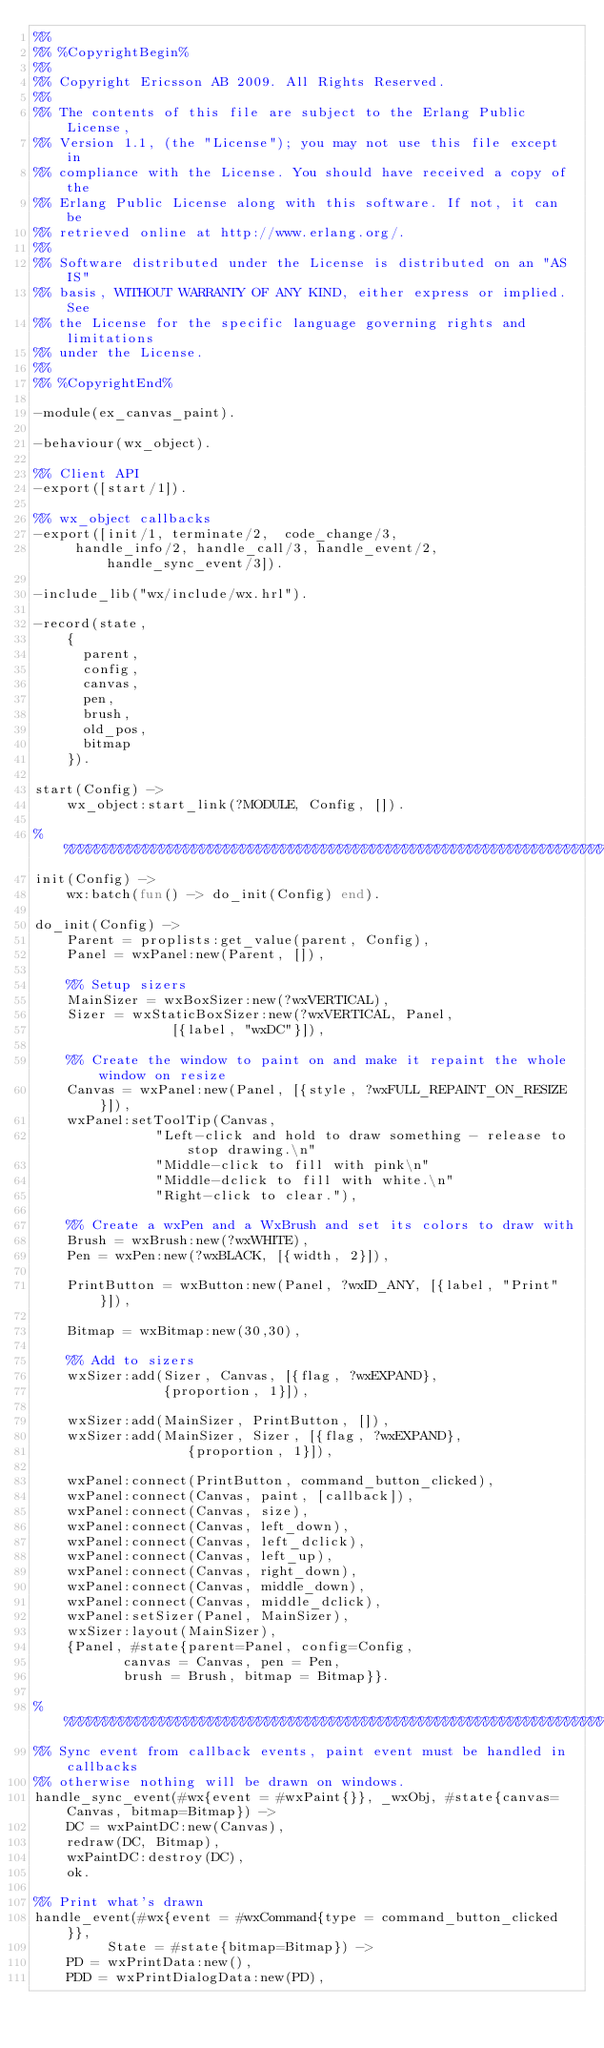Convert code to text. <code><loc_0><loc_0><loc_500><loc_500><_Erlang_>%%
%% %CopyrightBegin%
%% 
%% Copyright Ericsson AB 2009. All Rights Reserved.
%% 
%% The contents of this file are subject to the Erlang Public License,
%% Version 1.1, (the "License"); you may not use this file except in
%% compliance with the License. You should have received a copy of the
%% Erlang Public License along with this software. If not, it can be
%% retrieved online at http://www.erlang.org/.
%% 
%% Software distributed under the License is distributed on an "AS IS"
%% basis, WITHOUT WARRANTY OF ANY KIND, either express or implied. See
%% the License for the specific language governing rights and limitations
%% under the License.
%% 
%% %CopyrightEnd%

-module(ex_canvas_paint).

-behaviour(wx_object).

%% Client API
-export([start/1]).

%% wx_object callbacks
-export([init/1, terminate/2,  code_change/3,
	 handle_info/2, handle_call/3, handle_event/2, handle_sync_event/3]).

-include_lib("wx/include/wx.hrl").

-record(state, 
	{
	  parent,
	  config,
	  canvas,
	  pen,
	  brush,
	  old_pos,
	  bitmap
	}).

start(Config) ->
    wx_object:start_link(?MODULE, Config, []).

%%%%%%%%%%%%%%%%%%%%%%%%%%%%%%%%%%%%%%%%%%%%%%%%%%%%%%%%%%%%%%%%%%%%%%%%%%%%%%%
init(Config) ->
    wx:batch(fun() -> do_init(Config) end).

do_init(Config) ->
    Parent = proplists:get_value(parent, Config),  
    Panel = wxPanel:new(Parent, []),

    %% Setup sizers
    MainSizer = wxBoxSizer:new(?wxVERTICAL),
    Sizer = wxStaticBoxSizer:new(?wxVERTICAL, Panel, 
				 [{label, "wxDC"}]),
    
    %% Create the window to paint on and make it repaint the whole window on resize
    Canvas = wxPanel:new(Panel, [{style, ?wxFULL_REPAINT_ON_RESIZE}]),
    wxPanel:setToolTip(Canvas,
		       "Left-click and hold to draw something - release to stop drawing.\n"
		       "Middle-click to fill with pink\n"
		       "Middle-dclick to fill with white.\n"
		       "Right-click to clear."),

    %% Create a wxPen and a WxBrush and set its colors to draw with
    Brush = wxBrush:new(?wxWHITE),
    Pen = wxPen:new(?wxBLACK, [{width, 2}]),
    
    PrintButton = wxButton:new(Panel, ?wxID_ANY, [{label, "Print"}]),

    Bitmap = wxBitmap:new(30,30),

    %% Add to sizers
    wxSizer:add(Sizer, Canvas, [{flag, ?wxEXPAND},
				{proportion, 1}]),

    wxSizer:add(MainSizer, PrintButton, []),
    wxSizer:add(MainSizer, Sizer, [{flag, ?wxEXPAND},
				   {proportion, 1}]),
    
    wxPanel:connect(PrintButton, command_button_clicked),
    wxPanel:connect(Canvas, paint, [callback]),
    wxPanel:connect(Canvas, size),
    wxPanel:connect(Canvas, left_down),
    wxPanel:connect(Canvas, left_dclick),
    wxPanel:connect(Canvas, left_up),
    wxPanel:connect(Canvas, right_down),
    wxPanel:connect(Canvas, middle_down),
    wxPanel:connect(Canvas, middle_dclick),
    wxPanel:setSizer(Panel, MainSizer),
    wxSizer:layout(MainSizer),
    {Panel, #state{parent=Panel, config=Config,
		   canvas = Canvas, pen = Pen,
		   brush = Brush, bitmap = Bitmap}}.

%%%%%%%%%%%%%%%%%%%%%%%%%%%%%%%%%%%%%%%%%%%%%%%%%%%%%%%%%%%%%%%%%%%%%%%%%%%%%%%
%% Sync event from callback events, paint event must be handled in callbacks
%% otherwise nothing will be drawn on windows.
handle_sync_event(#wx{event = #wxPaint{}}, _wxObj, #state{canvas=Canvas, bitmap=Bitmap}) ->
    DC = wxPaintDC:new(Canvas),
    redraw(DC, Bitmap),
    wxPaintDC:destroy(DC),
    ok.

%% Print what's drawn
handle_event(#wx{event = #wxCommand{type = command_button_clicked}},
	     State = #state{bitmap=Bitmap}) ->
    PD = wxPrintData:new(),
    PDD = wxPrintDialogData:new(PD),</code> 